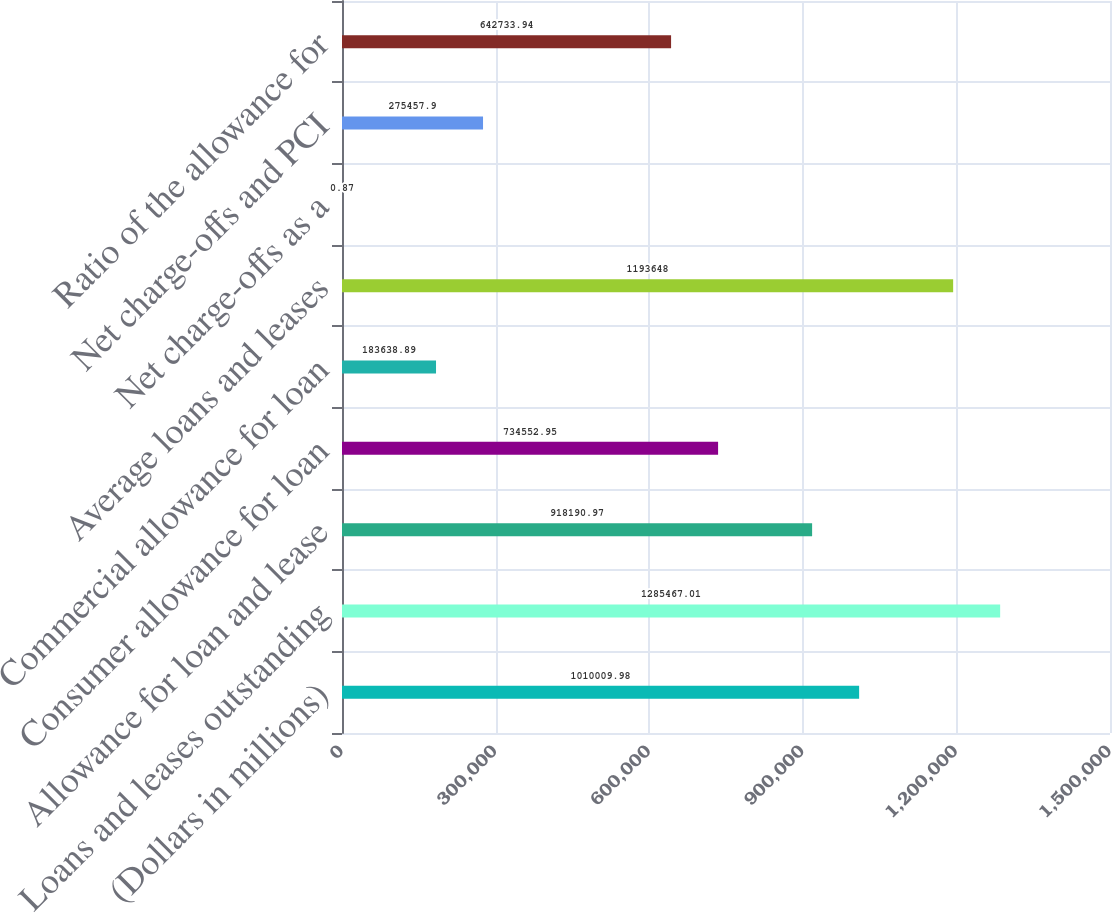Convert chart to OTSL. <chart><loc_0><loc_0><loc_500><loc_500><bar_chart><fcel>(Dollars in millions)<fcel>Loans and leases outstanding<fcel>Allowance for loan and lease<fcel>Consumer allowance for loan<fcel>Commercial allowance for loan<fcel>Average loans and leases<fcel>Net charge-offs as a<fcel>Net charge-offs and PCI<fcel>Ratio of the allowance for<nl><fcel>1.01001e+06<fcel>1.28547e+06<fcel>918191<fcel>734553<fcel>183639<fcel>1.19365e+06<fcel>0.87<fcel>275458<fcel>642734<nl></chart> 